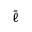<formula> <loc_0><loc_0><loc_500><loc_500>\bar { \ell }</formula> 